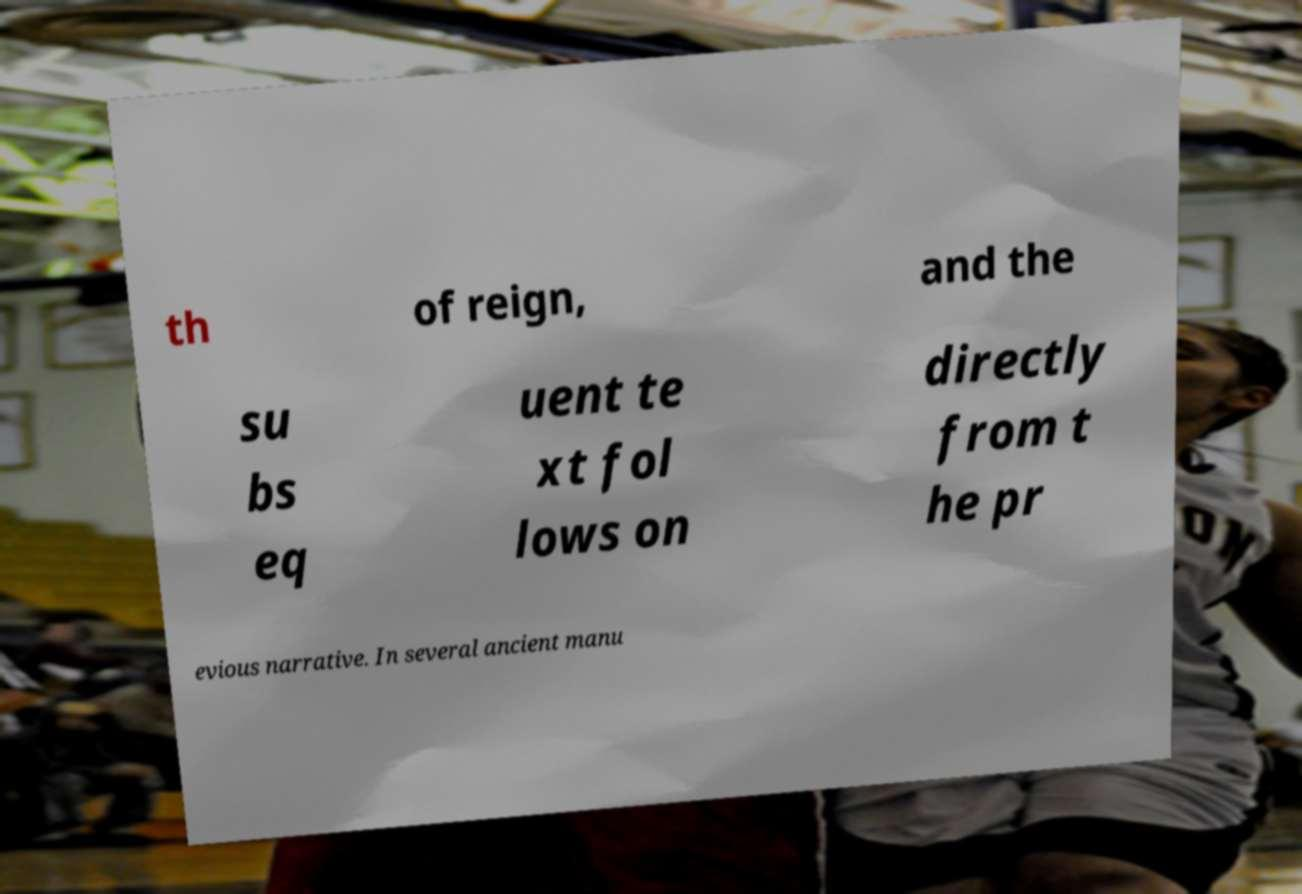Can you read and provide the text displayed in the image?This photo seems to have some interesting text. Can you extract and type it out for me? th of reign, and the su bs eq uent te xt fol lows on directly from t he pr evious narrative. In several ancient manu 